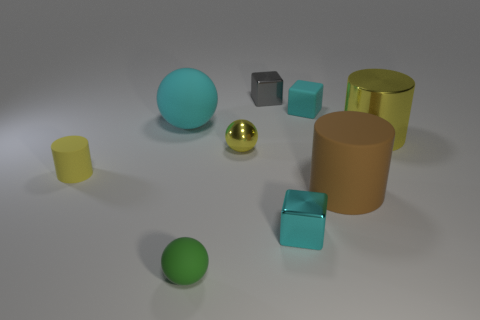Add 1 yellow cylinders. How many objects exist? 10 Subtract all spheres. How many objects are left? 6 Subtract all large things. Subtract all tiny metallic spheres. How many objects are left? 5 Add 1 small yellow rubber cylinders. How many small yellow rubber cylinders are left? 2 Add 8 brown cylinders. How many brown cylinders exist? 9 Subtract 0 gray spheres. How many objects are left? 9 